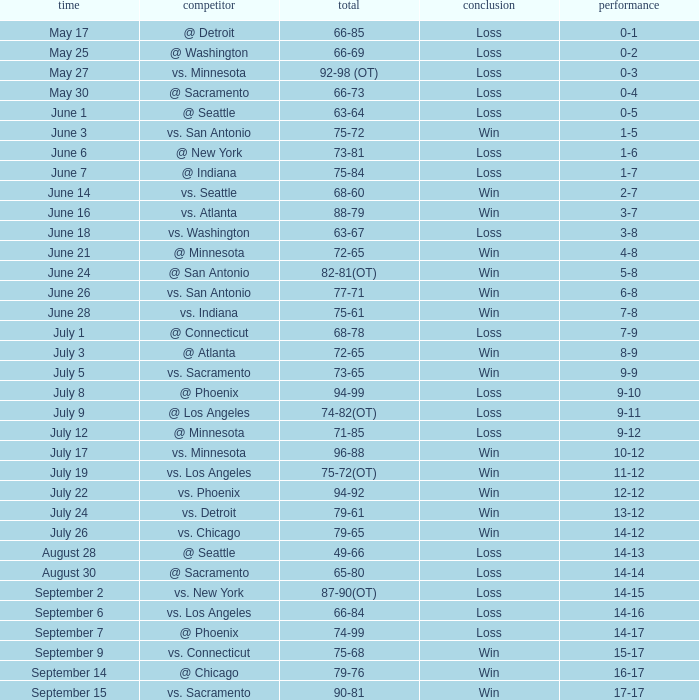Could you parse the entire table as a dict? {'header': ['time', 'competitor', 'total', 'conclusion', 'performance'], 'rows': [['May 17', '@ Detroit', '66-85', 'Loss', '0-1'], ['May 25', '@ Washington', '66-69', 'Loss', '0-2'], ['May 27', 'vs. Minnesota', '92-98 (OT)', 'Loss', '0-3'], ['May 30', '@ Sacramento', '66-73', 'Loss', '0-4'], ['June 1', '@ Seattle', '63-64', 'Loss', '0-5'], ['June 3', 'vs. San Antonio', '75-72', 'Win', '1-5'], ['June 6', '@ New York', '73-81', 'Loss', '1-6'], ['June 7', '@ Indiana', '75-84', 'Loss', '1-7'], ['June 14', 'vs. Seattle', '68-60', 'Win', '2-7'], ['June 16', 'vs. Atlanta', '88-79', 'Win', '3-7'], ['June 18', 'vs. Washington', '63-67', 'Loss', '3-8'], ['June 21', '@ Minnesota', '72-65', 'Win', '4-8'], ['June 24', '@ San Antonio', '82-81(OT)', 'Win', '5-8'], ['June 26', 'vs. San Antonio', '77-71', 'Win', '6-8'], ['June 28', 'vs. Indiana', '75-61', 'Win', '7-8'], ['July 1', '@ Connecticut', '68-78', 'Loss', '7-9'], ['July 3', '@ Atlanta', '72-65', 'Win', '8-9'], ['July 5', 'vs. Sacramento', '73-65', 'Win', '9-9'], ['July 8', '@ Phoenix', '94-99', 'Loss', '9-10'], ['July 9', '@ Los Angeles', '74-82(OT)', 'Loss', '9-11'], ['July 12', '@ Minnesota', '71-85', 'Loss', '9-12'], ['July 17', 'vs. Minnesota', '96-88', 'Win', '10-12'], ['July 19', 'vs. Los Angeles', '75-72(OT)', 'Win', '11-12'], ['July 22', 'vs. Phoenix', '94-92', 'Win', '12-12'], ['July 24', 'vs. Detroit', '79-61', 'Win', '13-12'], ['July 26', 'vs. Chicago', '79-65', 'Win', '14-12'], ['August 28', '@ Seattle', '49-66', 'Loss', '14-13'], ['August 30', '@ Sacramento', '65-80', 'Loss', '14-14'], ['September 2', 'vs. New York', '87-90(OT)', 'Loss', '14-15'], ['September 6', 'vs. Los Angeles', '66-84', 'Loss', '14-16'], ['September 7', '@ Phoenix', '74-99', 'Loss', '14-17'], ['September 9', 'vs. Connecticut', '75-68', 'Win', '15-17'], ['September 14', '@ Chicago', '79-76', 'Win', '16-17'], ['September 15', 'vs. Sacramento', '90-81', 'Win', '17-17']]} What is the Record on July 12? 9-12. 